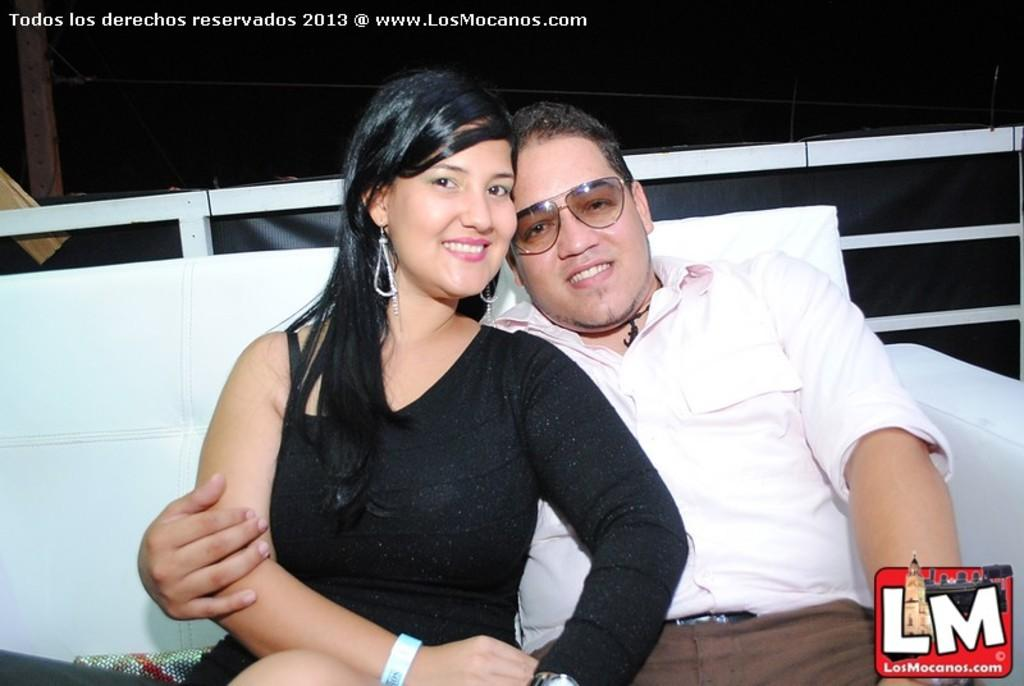Who is present in the image? There is a lady and a man in the image. What are they doing in the image? They are sitting on a couch. What can be seen at the top of the image? There is a wall visible at the top of the image. What type of watch is the lady wearing in the image? There is no watch visible on the lady in the image. How many women are present in the image? There is only one woman present in the image, which is the lady. 